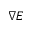Convert formula to latex. <formula><loc_0><loc_0><loc_500><loc_500>\nabla E</formula> 